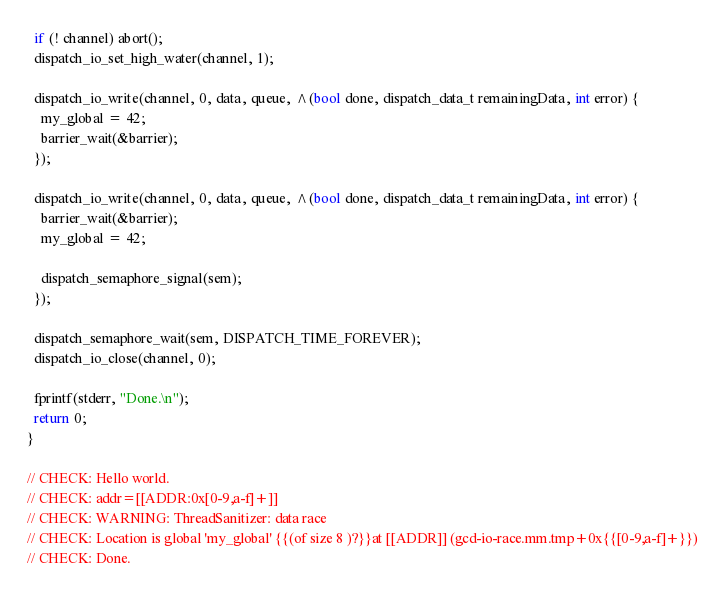Convert code to text. <code><loc_0><loc_0><loc_500><loc_500><_ObjectiveC_>  if (! channel) abort();
  dispatch_io_set_high_water(channel, 1);
  
  dispatch_io_write(channel, 0, data, queue, ^(bool done, dispatch_data_t remainingData, int error) {
    my_global = 42;
    barrier_wait(&barrier);
  });

  dispatch_io_write(channel, 0, data, queue, ^(bool done, dispatch_data_t remainingData, int error) {
    barrier_wait(&barrier);
    my_global = 42;

    dispatch_semaphore_signal(sem);
  });
  
  dispatch_semaphore_wait(sem, DISPATCH_TIME_FOREVER);
  dispatch_io_close(channel, 0);
  
  fprintf(stderr, "Done.\n");
  return 0;
}

// CHECK: Hello world.
// CHECK: addr=[[ADDR:0x[0-9,a-f]+]]
// CHECK: WARNING: ThreadSanitizer: data race
// CHECK: Location is global 'my_global' {{(of size 8 )?}}at [[ADDR]] (gcd-io-race.mm.tmp+0x{{[0-9,a-f]+}})
// CHECK: Done.
</code> 